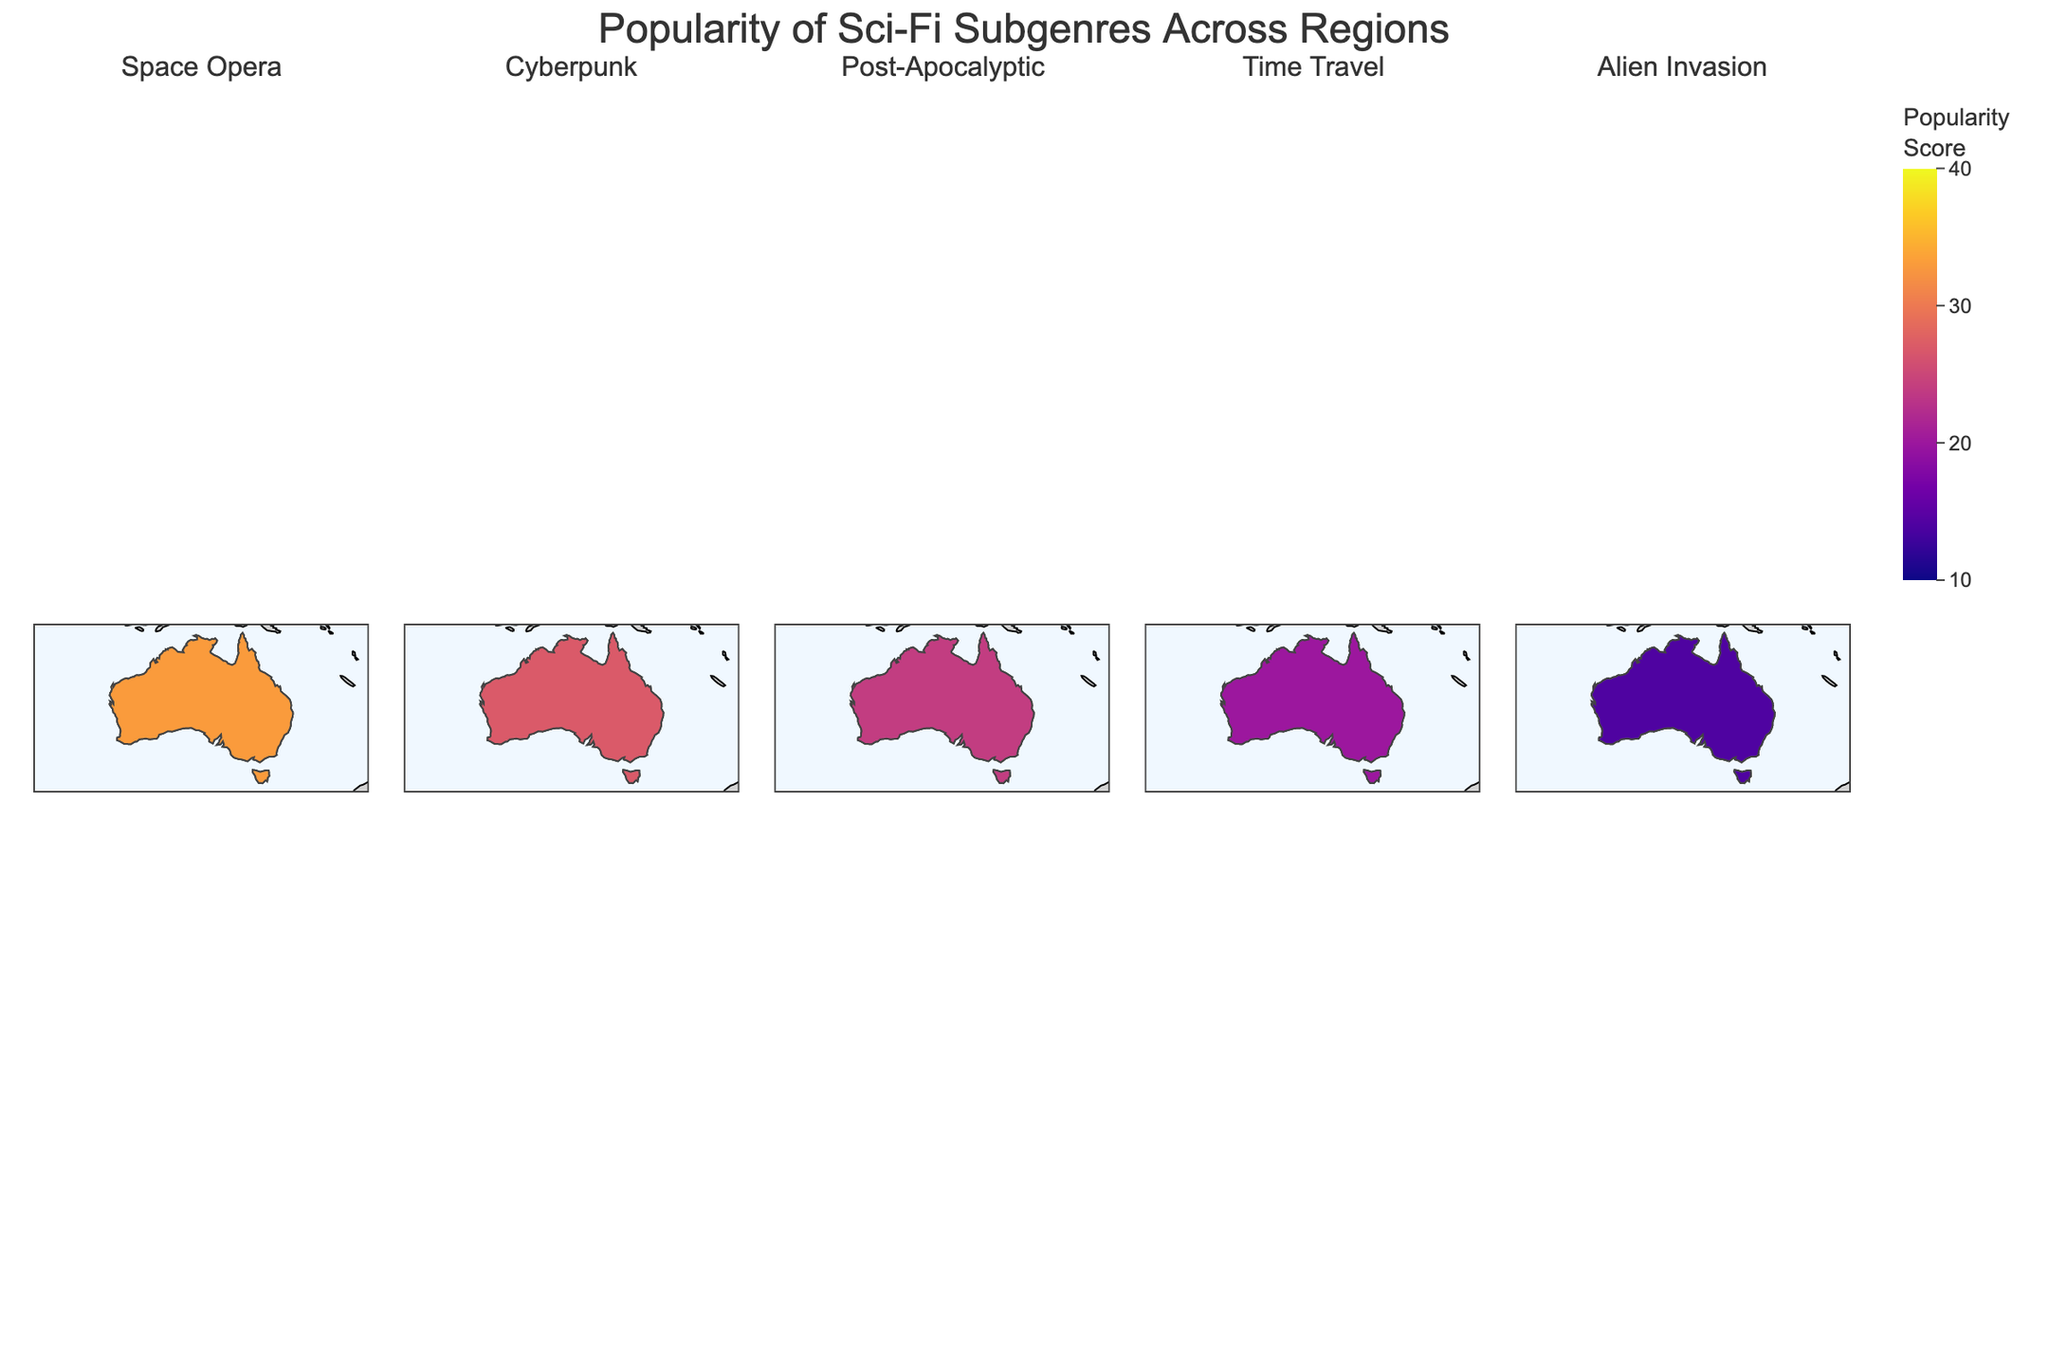What's the most popular science fiction subgenre in South Asia? According to the plot, the subgenre with the highest popularity score in South Asia is shown with the highest value. South Asia shows a popularity score of 30 for Alien Invasion, which is the highest among all subgenres in this region.
Answer: Alien Invasion Which region has the highest popularity score for Cyberpunk? Checking each region's score for Cyberpunk, Eastern Europe has the highest score with a value of 35, which is the maximum score for this subgenre.
Answer: Eastern Europe What is the combined popularity score for Space Opera and Time Travel in Western Europe? The popularity scores in Western Europe for Space Opera and Time Travel are 30 and 22 respectively. Adding these together gives 30 + 22 = 52.
Answer: 52 How does the popularity of Post-Apocalyptic in Middle East compare to that in Africa? The plot shows that Post-Apocalyptic has a popularity score of 35 in the Middle East and 32 in Africa. Comparing these, the Middle East has a higher score.
Answer: Middle East Which two regions have the closest popularity scores for Alien Invasion, and what are their scores? By examining the popularity scores for Alien Invasion, Western Europe and Australia/NZ both have scores of 14, making them the closest.
Answer: Western Europe and Australia/NZ, 14 What's the average popularity score of Time Travel across all regions? Summing up the Time Travel scores from all regions (18 + 22 + 15 + 20 + 15 + 18 + 25 + 20 + 28) gives 181. There are 9 regions, so the average is 181/9 ≈ 20.11.
Answer: 20.11 In which region is Space Opera more popular than Cyberpunk but less popular than Post-Apocalyptic? Comparing Space Opera, Cyberpunk, and Post-Apocalyptic scores, North America is the region where Space Opera (35) is more popular than Cyberpunk (28) but less popular than Post-Apocalyptic (22).
Answer: North America Identify the region with the lowest score for Time Travel and state the score. The plot shows that Eastern Europe has the lowest Time Travel score with a value of 15.
Answer: Eastern Europe, 15 How does the popularity of Alien Invasion in East Asia compare to South Asia? The plot indicates that the popularity score for Alien Invasion in East Asia is 25 while in South Asia it is 30. Thus, Alien Invasion is less popular in East Asia compared to South Asia.
Answer: Less popular in East Asia What is the second most popular science fiction subgenre in Africa? In Africa, the plot shows the following scores: Space Opera (22), Cyberpunk (18), Post-Apocalyptic (32), Time Travel (28), and Alien Invasion (18). The second highest score is for Time Travel, with a value of 28.
Answer: Time Travel 